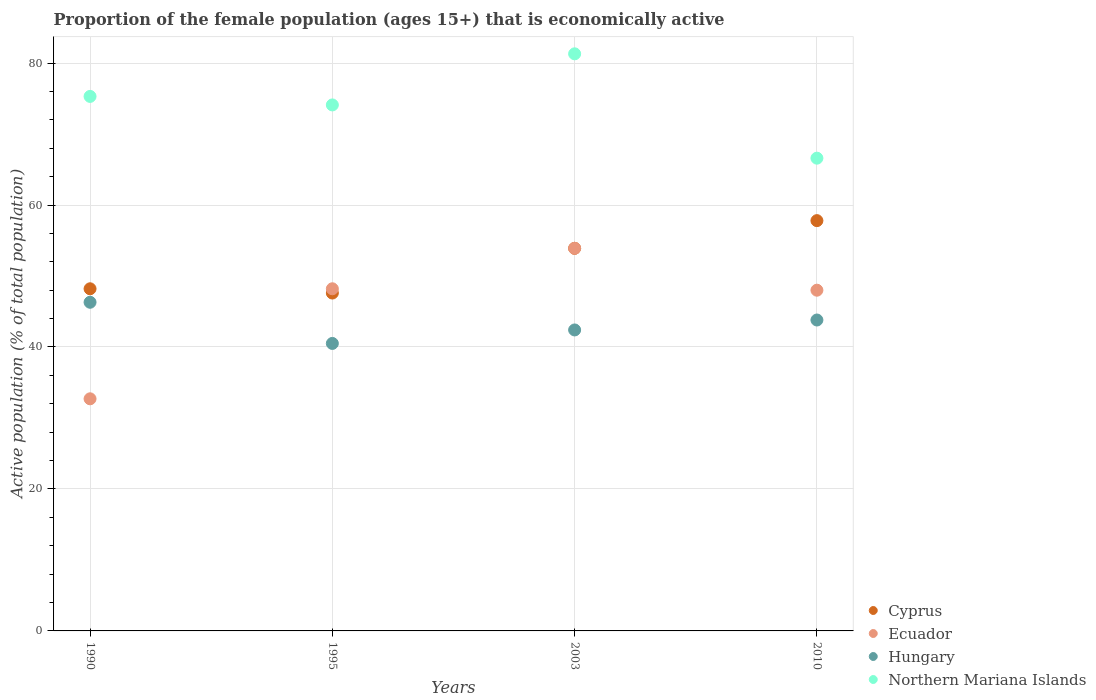How many different coloured dotlines are there?
Offer a very short reply. 4. What is the proportion of the female population that is economically active in Cyprus in 1990?
Keep it short and to the point. 48.2. Across all years, what is the maximum proportion of the female population that is economically active in Hungary?
Give a very brief answer. 46.3. Across all years, what is the minimum proportion of the female population that is economically active in Ecuador?
Offer a terse response. 32.7. In which year was the proportion of the female population that is economically active in Hungary minimum?
Offer a very short reply. 1995. What is the total proportion of the female population that is economically active in Hungary in the graph?
Give a very brief answer. 173. What is the difference between the proportion of the female population that is economically active in Hungary in 1990 and that in 1995?
Ensure brevity in your answer.  5.8. What is the difference between the proportion of the female population that is economically active in Hungary in 2003 and the proportion of the female population that is economically active in Cyprus in 1995?
Keep it short and to the point. -5.2. What is the average proportion of the female population that is economically active in Cyprus per year?
Your response must be concise. 51.88. In the year 1995, what is the difference between the proportion of the female population that is economically active in Northern Mariana Islands and proportion of the female population that is economically active in Ecuador?
Offer a very short reply. 25.9. In how many years, is the proportion of the female population that is economically active in Cyprus greater than 4 %?
Provide a succinct answer. 4. What is the ratio of the proportion of the female population that is economically active in Northern Mariana Islands in 1990 to that in 2010?
Give a very brief answer. 1.13. Is the difference between the proportion of the female population that is economically active in Northern Mariana Islands in 1990 and 1995 greater than the difference between the proportion of the female population that is economically active in Ecuador in 1990 and 1995?
Your answer should be very brief. Yes. What is the difference between the highest and the second highest proportion of the female population that is economically active in Ecuador?
Your answer should be compact. 5.7. What is the difference between the highest and the lowest proportion of the female population that is economically active in Ecuador?
Offer a terse response. 21.2. Is the sum of the proportion of the female population that is economically active in Hungary in 1995 and 2003 greater than the maximum proportion of the female population that is economically active in Ecuador across all years?
Give a very brief answer. Yes. Is it the case that in every year, the sum of the proportion of the female population that is economically active in Cyprus and proportion of the female population that is economically active in Hungary  is greater than the proportion of the female population that is economically active in Ecuador?
Your response must be concise. Yes. Does the proportion of the female population that is economically active in Hungary monotonically increase over the years?
Provide a short and direct response. No. Is the proportion of the female population that is economically active in Cyprus strictly greater than the proportion of the female population that is economically active in Hungary over the years?
Offer a very short reply. Yes. Is the proportion of the female population that is economically active in Northern Mariana Islands strictly less than the proportion of the female population that is economically active in Hungary over the years?
Make the answer very short. No. How many dotlines are there?
Your answer should be compact. 4. How many years are there in the graph?
Ensure brevity in your answer.  4. Are the values on the major ticks of Y-axis written in scientific E-notation?
Keep it short and to the point. No. Where does the legend appear in the graph?
Give a very brief answer. Bottom right. How many legend labels are there?
Your answer should be very brief. 4. How are the legend labels stacked?
Ensure brevity in your answer.  Vertical. What is the title of the graph?
Your answer should be very brief. Proportion of the female population (ages 15+) that is economically active. What is the label or title of the X-axis?
Give a very brief answer. Years. What is the label or title of the Y-axis?
Your answer should be compact. Active population (% of total population). What is the Active population (% of total population) of Cyprus in 1990?
Give a very brief answer. 48.2. What is the Active population (% of total population) of Ecuador in 1990?
Offer a very short reply. 32.7. What is the Active population (% of total population) of Hungary in 1990?
Offer a terse response. 46.3. What is the Active population (% of total population) in Northern Mariana Islands in 1990?
Offer a terse response. 75.3. What is the Active population (% of total population) of Cyprus in 1995?
Keep it short and to the point. 47.6. What is the Active population (% of total population) of Ecuador in 1995?
Provide a short and direct response. 48.2. What is the Active population (% of total population) of Hungary in 1995?
Ensure brevity in your answer.  40.5. What is the Active population (% of total population) of Northern Mariana Islands in 1995?
Your answer should be compact. 74.1. What is the Active population (% of total population) in Cyprus in 2003?
Your response must be concise. 53.9. What is the Active population (% of total population) in Ecuador in 2003?
Give a very brief answer. 53.9. What is the Active population (% of total population) of Hungary in 2003?
Keep it short and to the point. 42.4. What is the Active population (% of total population) in Northern Mariana Islands in 2003?
Ensure brevity in your answer.  81.3. What is the Active population (% of total population) of Cyprus in 2010?
Your answer should be compact. 57.8. What is the Active population (% of total population) in Hungary in 2010?
Keep it short and to the point. 43.8. What is the Active population (% of total population) of Northern Mariana Islands in 2010?
Provide a short and direct response. 66.6. Across all years, what is the maximum Active population (% of total population) of Cyprus?
Keep it short and to the point. 57.8. Across all years, what is the maximum Active population (% of total population) in Ecuador?
Offer a very short reply. 53.9. Across all years, what is the maximum Active population (% of total population) in Hungary?
Ensure brevity in your answer.  46.3. Across all years, what is the maximum Active population (% of total population) in Northern Mariana Islands?
Provide a succinct answer. 81.3. Across all years, what is the minimum Active population (% of total population) of Cyprus?
Ensure brevity in your answer.  47.6. Across all years, what is the minimum Active population (% of total population) in Ecuador?
Offer a terse response. 32.7. Across all years, what is the minimum Active population (% of total population) in Hungary?
Your answer should be very brief. 40.5. Across all years, what is the minimum Active population (% of total population) in Northern Mariana Islands?
Ensure brevity in your answer.  66.6. What is the total Active population (% of total population) of Cyprus in the graph?
Provide a short and direct response. 207.5. What is the total Active population (% of total population) of Ecuador in the graph?
Keep it short and to the point. 182.8. What is the total Active population (% of total population) in Hungary in the graph?
Your answer should be compact. 173. What is the total Active population (% of total population) of Northern Mariana Islands in the graph?
Provide a short and direct response. 297.3. What is the difference between the Active population (% of total population) in Ecuador in 1990 and that in 1995?
Your answer should be very brief. -15.5. What is the difference between the Active population (% of total population) of Hungary in 1990 and that in 1995?
Give a very brief answer. 5.8. What is the difference between the Active population (% of total population) in Northern Mariana Islands in 1990 and that in 1995?
Your answer should be very brief. 1.2. What is the difference between the Active population (% of total population) of Ecuador in 1990 and that in 2003?
Provide a succinct answer. -21.2. What is the difference between the Active population (% of total population) of Cyprus in 1990 and that in 2010?
Your answer should be very brief. -9.6. What is the difference between the Active population (% of total population) of Ecuador in 1990 and that in 2010?
Offer a very short reply. -15.3. What is the difference between the Active population (% of total population) of Cyprus in 1995 and that in 2003?
Keep it short and to the point. -6.3. What is the difference between the Active population (% of total population) of Ecuador in 1995 and that in 2003?
Provide a short and direct response. -5.7. What is the difference between the Active population (% of total population) of Northern Mariana Islands in 1995 and that in 2003?
Give a very brief answer. -7.2. What is the difference between the Active population (% of total population) of Ecuador in 1995 and that in 2010?
Offer a terse response. 0.2. What is the difference between the Active population (% of total population) in Northern Mariana Islands in 1995 and that in 2010?
Provide a short and direct response. 7.5. What is the difference between the Active population (% of total population) of Cyprus in 2003 and that in 2010?
Your answer should be compact. -3.9. What is the difference between the Active population (% of total population) of Ecuador in 2003 and that in 2010?
Your response must be concise. 5.9. What is the difference between the Active population (% of total population) of Northern Mariana Islands in 2003 and that in 2010?
Give a very brief answer. 14.7. What is the difference between the Active population (% of total population) in Cyprus in 1990 and the Active population (% of total population) in Ecuador in 1995?
Keep it short and to the point. 0. What is the difference between the Active population (% of total population) of Cyprus in 1990 and the Active population (% of total population) of Northern Mariana Islands in 1995?
Make the answer very short. -25.9. What is the difference between the Active population (% of total population) of Ecuador in 1990 and the Active population (% of total population) of Hungary in 1995?
Provide a short and direct response. -7.8. What is the difference between the Active population (% of total population) of Ecuador in 1990 and the Active population (% of total population) of Northern Mariana Islands in 1995?
Provide a short and direct response. -41.4. What is the difference between the Active population (% of total population) in Hungary in 1990 and the Active population (% of total population) in Northern Mariana Islands in 1995?
Make the answer very short. -27.8. What is the difference between the Active population (% of total population) of Cyprus in 1990 and the Active population (% of total population) of Ecuador in 2003?
Provide a short and direct response. -5.7. What is the difference between the Active population (% of total population) of Cyprus in 1990 and the Active population (% of total population) of Hungary in 2003?
Your answer should be compact. 5.8. What is the difference between the Active population (% of total population) in Cyprus in 1990 and the Active population (% of total population) in Northern Mariana Islands in 2003?
Your answer should be very brief. -33.1. What is the difference between the Active population (% of total population) in Ecuador in 1990 and the Active population (% of total population) in Hungary in 2003?
Make the answer very short. -9.7. What is the difference between the Active population (% of total population) in Ecuador in 1990 and the Active population (% of total population) in Northern Mariana Islands in 2003?
Give a very brief answer. -48.6. What is the difference between the Active population (% of total population) in Hungary in 1990 and the Active population (% of total population) in Northern Mariana Islands in 2003?
Offer a very short reply. -35. What is the difference between the Active population (% of total population) of Cyprus in 1990 and the Active population (% of total population) of Northern Mariana Islands in 2010?
Provide a succinct answer. -18.4. What is the difference between the Active population (% of total population) of Ecuador in 1990 and the Active population (% of total population) of Northern Mariana Islands in 2010?
Provide a short and direct response. -33.9. What is the difference between the Active population (% of total population) in Hungary in 1990 and the Active population (% of total population) in Northern Mariana Islands in 2010?
Your answer should be compact. -20.3. What is the difference between the Active population (% of total population) in Cyprus in 1995 and the Active population (% of total population) in Northern Mariana Islands in 2003?
Your answer should be compact. -33.7. What is the difference between the Active population (% of total population) in Ecuador in 1995 and the Active population (% of total population) in Hungary in 2003?
Ensure brevity in your answer.  5.8. What is the difference between the Active population (% of total population) in Ecuador in 1995 and the Active population (% of total population) in Northern Mariana Islands in 2003?
Provide a succinct answer. -33.1. What is the difference between the Active population (% of total population) in Hungary in 1995 and the Active population (% of total population) in Northern Mariana Islands in 2003?
Offer a very short reply. -40.8. What is the difference between the Active population (% of total population) of Cyprus in 1995 and the Active population (% of total population) of Ecuador in 2010?
Make the answer very short. -0.4. What is the difference between the Active population (% of total population) in Cyprus in 1995 and the Active population (% of total population) in Northern Mariana Islands in 2010?
Your answer should be compact. -19. What is the difference between the Active population (% of total population) in Ecuador in 1995 and the Active population (% of total population) in Northern Mariana Islands in 2010?
Ensure brevity in your answer.  -18.4. What is the difference between the Active population (% of total population) in Hungary in 1995 and the Active population (% of total population) in Northern Mariana Islands in 2010?
Your response must be concise. -26.1. What is the difference between the Active population (% of total population) in Cyprus in 2003 and the Active population (% of total population) in Northern Mariana Islands in 2010?
Ensure brevity in your answer.  -12.7. What is the difference between the Active population (% of total population) in Ecuador in 2003 and the Active population (% of total population) in Hungary in 2010?
Give a very brief answer. 10.1. What is the difference between the Active population (% of total population) of Hungary in 2003 and the Active population (% of total population) of Northern Mariana Islands in 2010?
Your answer should be compact. -24.2. What is the average Active population (% of total population) in Cyprus per year?
Offer a terse response. 51.88. What is the average Active population (% of total population) of Ecuador per year?
Give a very brief answer. 45.7. What is the average Active population (% of total population) in Hungary per year?
Keep it short and to the point. 43.25. What is the average Active population (% of total population) in Northern Mariana Islands per year?
Make the answer very short. 74.33. In the year 1990, what is the difference between the Active population (% of total population) in Cyprus and Active population (% of total population) in Ecuador?
Offer a terse response. 15.5. In the year 1990, what is the difference between the Active population (% of total population) of Cyprus and Active population (% of total population) of Hungary?
Keep it short and to the point. 1.9. In the year 1990, what is the difference between the Active population (% of total population) in Cyprus and Active population (% of total population) in Northern Mariana Islands?
Provide a short and direct response. -27.1. In the year 1990, what is the difference between the Active population (% of total population) of Ecuador and Active population (% of total population) of Hungary?
Provide a short and direct response. -13.6. In the year 1990, what is the difference between the Active population (% of total population) in Ecuador and Active population (% of total population) in Northern Mariana Islands?
Provide a succinct answer. -42.6. In the year 1990, what is the difference between the Active population (% of total population) of Hungary and Active population (% of total population) of Northern Mariana Islands?
Ensure brevity in your answer.  -29. In the year 1995, what is the difference between the Active population (% of total population) in Cyprus and Active population (% of total population) in Ecuador?
Ensure brevity in your answer.  -0.6. In the year 1995, what is the difference between the Active population (% of total population) in Cyprus and Active population (% of total population) in Northern Mariana Islands?
Keep it short and to the point. -26.5. In the year 1995, what is the difference between the Active population (% of total population) in Ecuador and Active population (% of total population) in Hungary?
Your response must be concise. 7.7. In the year 1995, what is the difference between the Active population (% of total population) in Ecuador and Active population (% of total population) in Northern Mariana Islands?
Give a very brief answer. -25.9. In the year 1995, what is the difference between the Active population (% of total population) in Hungary and Active population (% of total population) in Northern Mariana Islands?
Give a very brief answer. -33.6. In the year 2003, what is the difference between the Active population (% of total population) of Cyprus and Active population (% of total population) of Ecuador?
Give a very brief answer. 0. In the year 2003, what is the difference between the Active population (% of total population) in Cyprus and Active population (% of total population) in Hungary?
Your answer should be very brief. 11.5. In the year 2003, what is the difference between the Active population (% of total population) of Cyprus and Active population (% of total population) of Northern Mariana Islands?
Offer a terse response. -27.4. In the year 2003, what is the difference between the Active population (% of total population) in Ecuador and Active population (% of total population) in Northern Mariana Islands?
Provide a succinct answer. -27.4. In the year 2003, what is the difference between the Active population (% of total population) of Hungary and Active population (% of total population) of Northern Mariana Islands?
Your response must be concise. -38.9. In the year 2010, what is the difference between the Active population (% of total population) of Cyprus and Active population (% of total population) of Hungary?
Ensure brevity in your answer.  14. In the year 2010, what is the difference between the Active population (% of total population) of Ecuador and Active population (% of total population) of Hungary?
Give a very brief answer. 4.2. In the year 2010, what is the difference between the Active population (% of total population) of Ecuador and Active population (% of total population) of Northern Mariana Islands?
Your answer should be compact. -18.6. In the year 2010, what is the difference between the Active population (% of total population) of Hungary and Active population (% of total population) of Northern Mariana Islands?
Keep it short and to the point. -22.8. What is the ratio of the Active population (% of total population) in Cyprus in 1990 to that in 1995?
Provide a succinct answer. 1.01. What is the ratio of the Active population (% of total population) of Ecuador in 1990 to that in 1995?
Ensure brevity in your answer.  0.68. What is the ratio of the Active population (% of total population) in Hungary in 1990 to that in 1995?
Provide a short and direct response. 1.14. What is the ratio of the Active population (% of total population) of Northern Mariana Islands in 1990 to that in 1995?
Provide a short and direct response. 1.02. What is the ratio of the Active population (% of total population) in Cyprus in 1990 to that in 2003?
Keep it short and to the point. 0.89. What is the ratio of the Active population (% of total population) in Ecuador in 1990 to that in 2003?
Offer a terse response. 0.61. What is the ratio of the Active population (% of total population) of Hungary in 1990 to that in 2003?
Offer a terse response. 1.09. What is the ratio of the Active population (% of total population) of Northern Mariana Islands in 1990 to that in 2003?
Your response must be concise. 0.93. What is the ratio of the Active population (% of total population) in Cyprus in 1990 to that in 2010?
Offer a very short reply. 0.83. What is the ratio of the Active population (% of total population) in Ecuador in 1990 to that in 2010?
Keep it short and to the point. 0.68. What is the ratio of the Active population (% of total population) in Hungary in 1990 to that in 2010?
Your answer should be very brief. 1.06. What is the ratio of the Active population (% of total population) in Northern Mariana Islands in 1990 to that in 2010?
Provide a short and direct response. 1.13. What is the ratio of the Active population (% of total population) in Cyprus in 1995 to that in 2003?
Keep it short and to the point. 0.88. What is the ratio of the Active population (% of total population) of Ecuador in 1995 to that in 2003?
Offer a very short reply. 0.89. What is the ratio of the Active population (% of total population) in Hungary in 1995 to that in 2003?
Ensure brevity in your answer.  0.96. What is the ratio of the Active population (% of total population) of Northern Mariana Islands in 1995 to that in 2003?
Make the answer very short. 0.91. What is the ratio of the Active population (% of total population) of Cyprus in 1995 to that in 2010?
Make the answer very short. 0.82. What is the ratio of the Active population (% of total population) in Hungary in 1995 to that in 2010?
Provide a succinct answer. 0.92. What is the ratio of the Active population (% of total population) of Northern Mariana Islands in 1995 to that in 2010?
Provide a short and direct response. 1.11. What is the ratio of the Active population (% of total population) in Cyprus in 2003 to that in 2010?
Your answer should be very brief. 0.93. What is the ratio of the Active population (% of total population) in Ecuador in 2003 to that in 2010?
Your response must be concise. 1.12. What is the ratio of the Active population (% of total population) in Hungary in 2003 to that in 2010?
Provide a short and direct response. 0.97. What is the ratio of the Active population (% of total population) of Northern Mariana Islands in 2003 to that in 2010?
Provide a short and direct response. 1.22. What is the difference between the highest and the second highest Active population (% of total population) of Cyprus?
Make the answer very short. 3.9. What is the difference between the highest and the second highest Active population (% of total population) in Hungary?
Offer a very short reply. 2.5. What is the difference between the highest and the second highest Active population (% of total population) in Northern Mariana Islands?
Make the answer very short. 6. What is the difference between the highest and the lowest Active population (% of total population) of Ecuador?
Offer a very short reply. 21.2. 